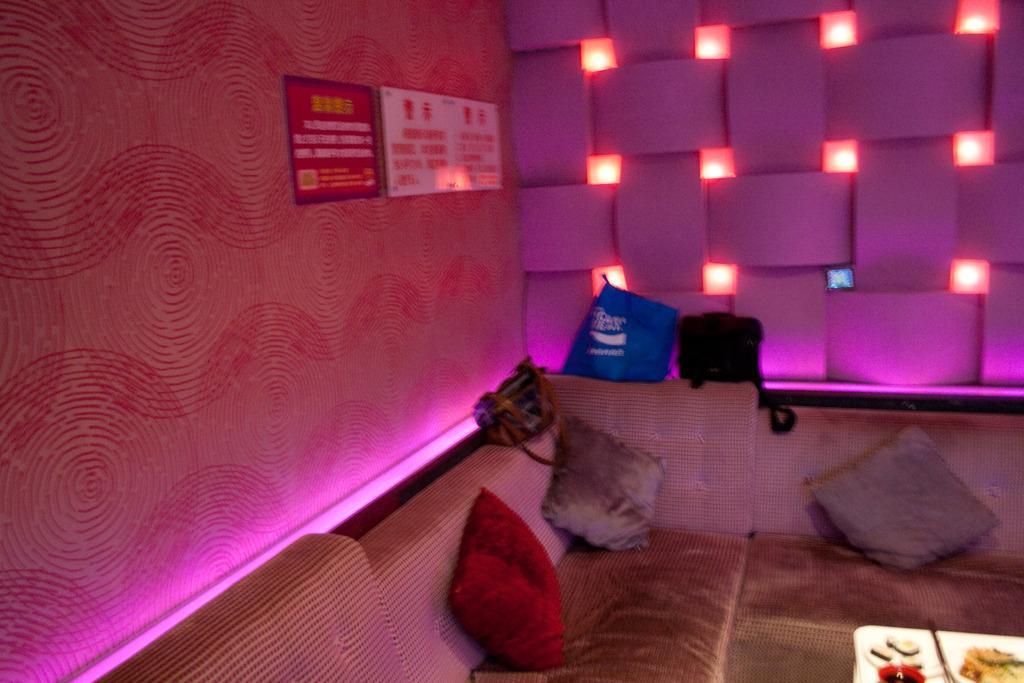How would you summarize this image in a sentence or two? In this image we can see a sofa on which some bags are there and a board is there on which a text was written. 